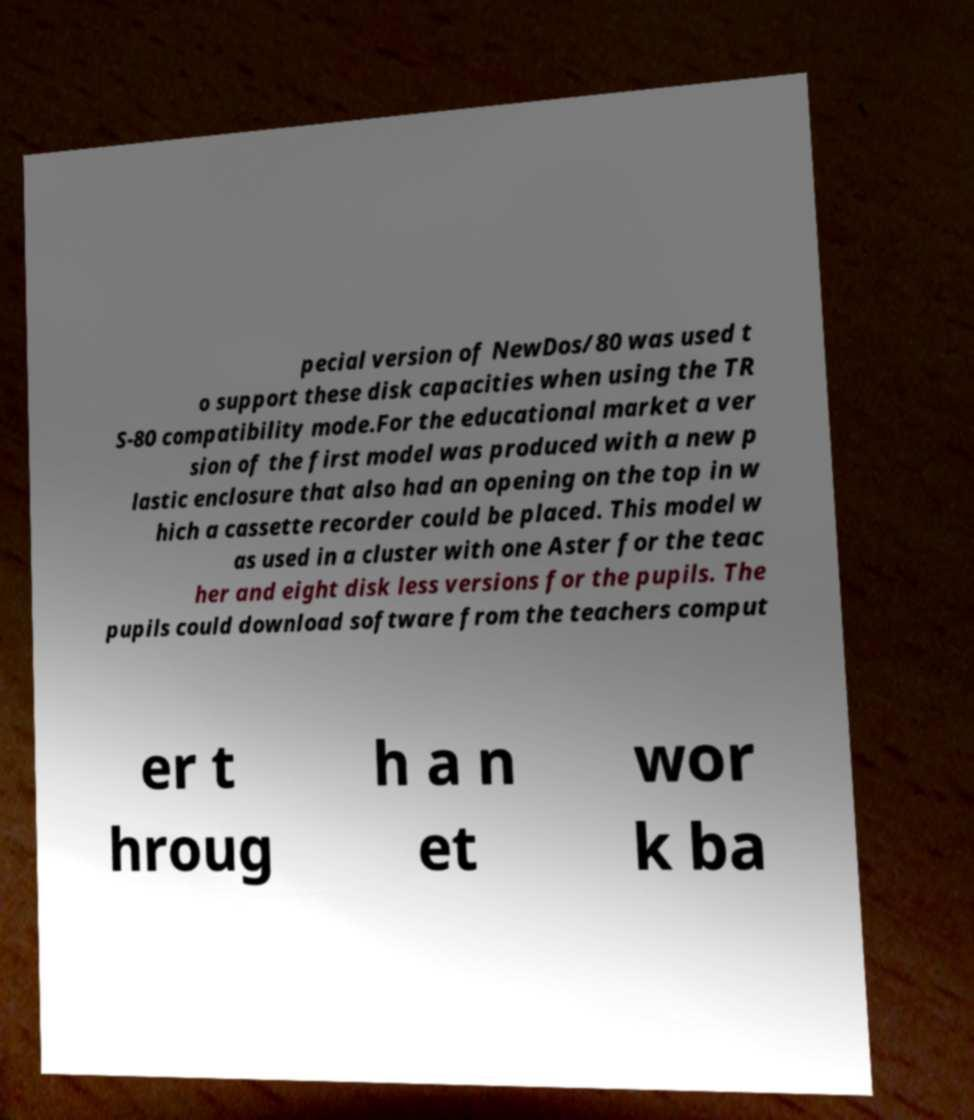Please identify and transcribe the text found in this image. pecial version of NewDos/80 was used t o support these disk capacities when using the TR S-80 compatibility mode.For the educational market a ver sion of the first model was produced with a new p lastic enclosure that also had an opening on the top in w hich a cassette recorder could be placed. This model w as used in a cluster with one Aster for the teac her and eight disk less versions for the pupils. The pupils could download software from the teachers comput er t hroug h a n et wor k ba 